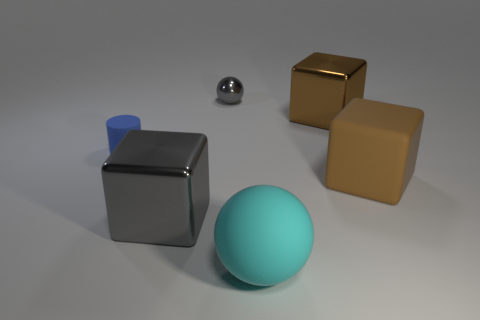Add 4 small objects. How many objects exist? 10 Subtract all balls. How many objects are left? 4 Add 1 large rubber objects. How many large rubber objects are left? 3 Add 6 tiny metal spheres. How many tiny metal spheres exist? 7 Subtract 0 red cylinders. How many objects are left? 6 Subtract all big cyan matte things. Subtract all large cyan balls. How many objects are left? 4 